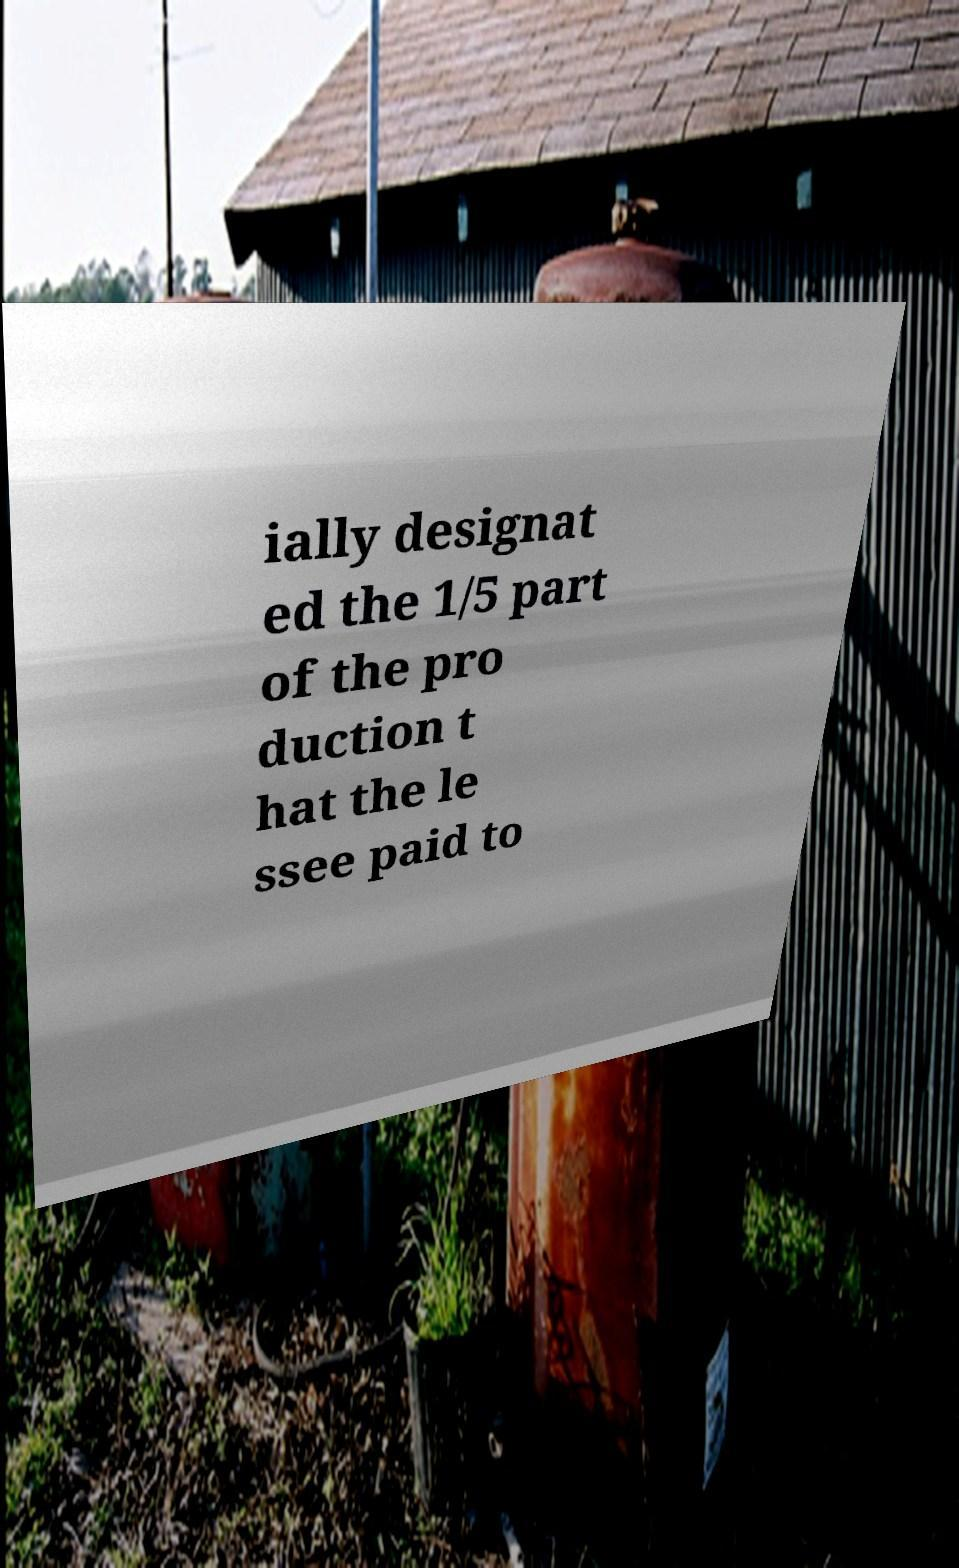Can you read and provide the text displayed in the image?This photo seems to have some interesting text. Can you extract and type it out for me? ially designat ed the 1/5 part of the pro duction t hat the le ssee paid to 